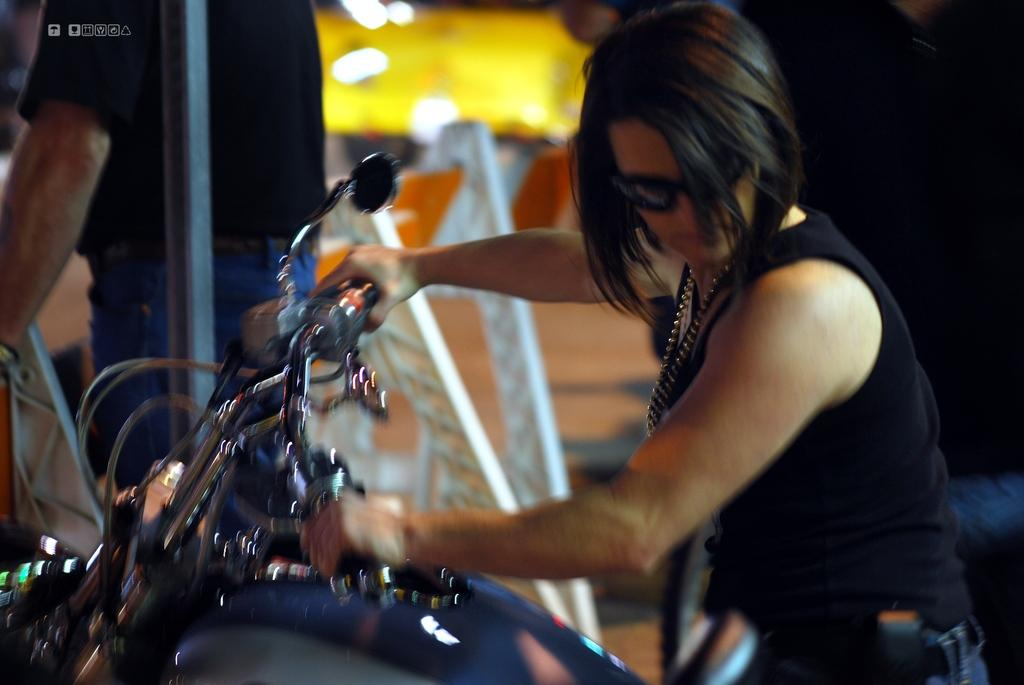What is the main subject of the image? There is a person in the image. What is the person doing in the image? The person is on a bike. What type of whip is the person holding while riding the bike in the image? There is no whip present in the image; the person is simply riding a bike. 